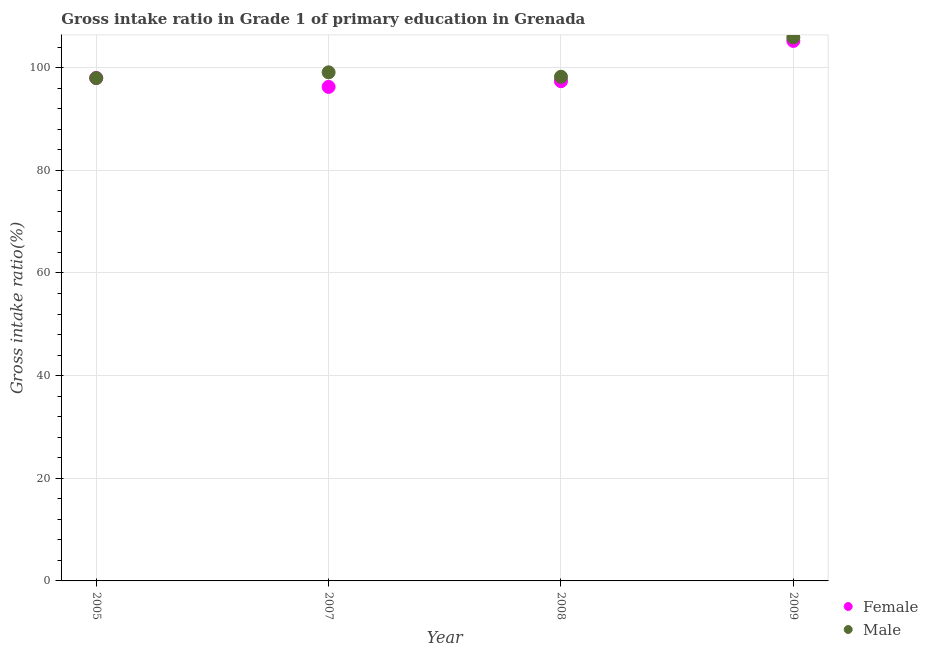What is the gross intake ratio(male) in 2005?
Offer a terse response. 97.96. Across all years, what is the maximum gross intake ratio(male)?
Provide a succinct answer. 105.89. Across all years, what is the minimum gross intake ratio(female)?
Provide a short and direct response. 96.24. In which year was the gross intake ratio(female) minimum?
Give a very brief answer. 2007. What is the total gross intake ratio(female) in the graph?
Provide a succinct answer. 396.77. What is the difference between the gross intake ratio(female) in 2005 and that in 2008?
Offer a terse response. 0.62. What is the difference between the gross intake ratio(male) in 2007 and the gross intake ratio(female) in 2008?
Keep it short and to the point. 1.73. What is the average gross intake ratio(female) per year?
Offer a terse response. 99.19. In the year 2008, what is the difference between the gross intake ratio(male) and gross intake ratio(female)?
Offer a terse response. 0.87. In how many years, is the gross intake ratio(male) greater than 64 %?
Provide a short and direct response. 4. What is the ratio of the gross intake ratio(female) in 2007 to that in 2008?
Make the answer very short. 0.99. What is the difference between the highest and the second highest gross intake ratio(female)?
Your response must be concise. 7.23. What is the difference between the highest and the lowest gross intake ratio(female)?
Offer a very short reply. 8.96. Is the gross intake ratio(male) strictly greater than the gross intake ratio(female) over the years?
Keep it short and to the point. No. Are the values on the major ticks of Y-axis written in scientific E-notation?
Offer a terse response. No. Where does the legend appear in the graph?
Provide a succinct answer. Bottom right. How many legend labels are there?
Your answer should be very brief. 2. What is the title of the graph?
Your answer should be very brief. Gross intake ratio in Grade 1 of primary education in Grenada. What is the label or title of the X-axis?
Make the answer very short. Year. What is the label or title of the Y-axis?
Provide a succinct answer. Gross intake ratio(%). What is the Gross intake ratio(%) of Female in 2005?
Your response must be concise. 97.97. What is the Gross intake ratio(%) in Male in 2005?
Your answer should be very brief. 97.96. What is the Gross intake ratio(%) of Female in 2007?
Ensure brevity in your answer.  96.24. What is the Gross intake ratio(%) in Male in 2007?
Your response must be concise. 99.08. What is the Gross intake ratio(%) of Female in 2008?
Provide a succinct answer. 97.35. What is the Gross intake ratio(%) in Male in 2008?
Your answer should be compact. 98.22. What is the Gross intake ratio(%) of Female in 2009?
Provide a short and direct response. 105.2. What is the Gross intake ratio(%) of Male in 2009?
Offer a terse response. 105.89. Across all years, what is the maximum Gross intake ratio(%) in Female?
Your answer should be very brief. 105.2. Across all years, what is the maximum Gross intake ratio(%) of Male?
Keep it short and to the point. 105.89. Across all years, what is the minimum Gross intake ratio(%) of Female?
Provide a succinct answer. 96.24. Across all years, what is the minimum Gross intake ratio(%) of Male?
Offer a terse response. 97.96. What is the total Gross intake ratio(%) in Female in the graph?
Keep it short and to the point. 396.77. What is the total Gross intake ratio(%) of Male in the graph?
Your answer should be very brief. 401.16. What is the difference between the Gross intake ratio(%) in Female in 2005 and that in 2007?
Offer a terse response. 1.73. What is the difference between the Gross intake ratio(%) in Male in 2005 and that in 2007?
Your answer should be compact. -1.12. What is the difference between the Gross intake ratio(%) in Female in 2005 and that in 2008?
Your response must be concise. 0.62. What is the difference between the Gross intake ratio(%) in Male in 2005 and that in 2008?
Give a very brief answer. -0.26. What is the difference between the Gross intake ratio(%) in Female in 2005 and that in 2009?
Offer a terse response. -7.23. What is the difference between the Gross intake ratio(%) of Male in 2005 and that in 2009?
Keep it short and to the point. -7.94. What is the difference between the Gross intake ratio(%) of Female in 2007 and that in 2008?
Keep it short and to the point. -1.11. What is the difference between the Gross intake ratio(%) of Male in 2007 and that in 2008?
Offer a terse response. 0.86. What is the difference between the Gross intake ratio(%) in Female in 2007 and that in 2009?
Give a very brief answer. -8.96. What is the difference between the Gross intake ratio(%) of Male in 2007 and that in 2009?
Keep it short and to the point. -6.81. What is the difference between the Gross intake ratio(%) in Female in 2008 and that in 2009?
Provide a succinct answer. -7.85. What is the difference between the Gross intake ratio(%) of Male in 2008 and that in 2009?
Provide a succinct answer. -7.68. What is the difference between the Gross intake ratio(%) of Female in 2005 and the Gross intake ratio(%) of Male in 2007?
Provide a succinct answer. -1.11. What is the difference between the Gross intake ratio(%) of Female in 2005 and the Gross intake ratio(%) of Male in 2008?
Keep it short and to the point. -0.25. What is the difference between the Gross intake ratio(%) of Female in 2005 and the Gross intake ratio(%) of Male in 2009?
Offer a very short reply. -7.92. What is the difference between the Gross intake ratio(%) in Female in 2007 and the Gross intake ratio(%) in Male in 2008?
Your answer should be compact. -1.98. What is the difference between the Gross intake ratio(%) in Female in 2007 and the Gross intake ratio(%) in Male in 2009?
Your answer should be compact. -9.65. What is the difference between the Gross intake ratio(%) in Female in 2008 and the Gross intake ratio(%) in Male in 2009?
Your response must be concise. -8.54. What is the average Gross intake ratio(%) of Female per year?
Make the answer very short. 99.19. What is the average Gross intake ratio(%) in Male per year?
Your answer should be compact. 100.29. In the year 2005, what is the difference between the Gross intake ratio(%) of Female and Gross intake ratio(%) of Male?
Provide a succinct answer. 0.01. In the year 2007, what is the difference between the Gross intake ratio(%) of Female and Gross intake ratio(%) of Male?
Make the answer very short. -2.84. In the year 2008, what is the difference between the Gross intake ratio(%) of Female and Gross intake ratio(%) of Male?
Offer a terse response. -0.87. In the year 2009, what is the difference between the Gross intake ratio(%) of Female and Gross intake ratio(%) of Male?
Your answer should be very brief. -0.69. What is the ratio of the Gross intake ratio(%) of Male in 2005 to that in 2007?
Give a very brief answer. 0.99. What is the ratio of the Gross intake ratio(%) in Female in 2005 to that in 2008?
Give a very brief answer. 1.01. What is the ratio of the Gross intake ratio(%) of Male in 2005 to that in 2008?
Your response must be concise. 1. What is the ratio of the Gross intake ratio(%) of Female in 2005 to that in 2009?
Offer a very short reply. 0.93. What is the ratio of the Gross intake ratio(%) in Male in 2005 to that in 2009?
Your answer should be very brief. 0.93. What is the ratio of the Gross intake ratio(%) in Male in 2007 to that in 2008?
Give a very brief answer. 1.01. What is the ratio of the Gross intake ratio(%) of Female in 2007 to that in 2009?
Provide a succinct answer. 0.91. What is the ratio of the Gross intake ratio(%) in Male in 2007 to that in 2009?
Offer a terse response. 0.94. What is the ratio of the Gross intake ratio(%) in Female in 2008 to that in 2009?
Ensure brevity in your answer.  0.93. What is the ratio of the Gross intake ratio(%) in Male in 2008 to that in 2009?
Ensure brevity in your answer.  0.93. What is the difference between the highest and the second highest Gross intake ratio(%) in Female?
Ensure brevity in your answer.  7.23. What is the difference between the highest and the second highest Gross intake ratio(%) in Male?
Keep it short and to the point. 6.81. What is the difference between the highest and the lowest Gross intake ratio(%) of Female?
Provide a short and direct response. 8.96. What is the difference between the highest and the lowest Gross intake ratio(%) in Male?
Ensure brevity in your answer.  7.94. 